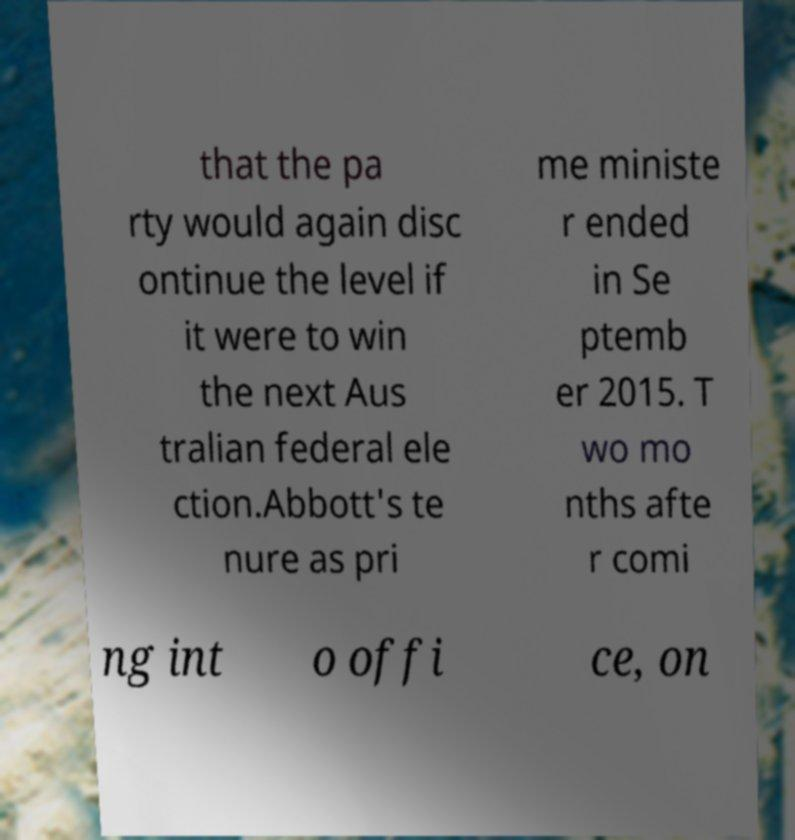Can you accurately transcribe the text from the provided image for me? that the pa rty would again disc ontinue the level if it were to win the next Aus tralian federal ele ction.Abbott's te nure as pri me ministe r ended in Se ptemb er 2015. T wo mo nths afte r comi ng int o offi ce, on 